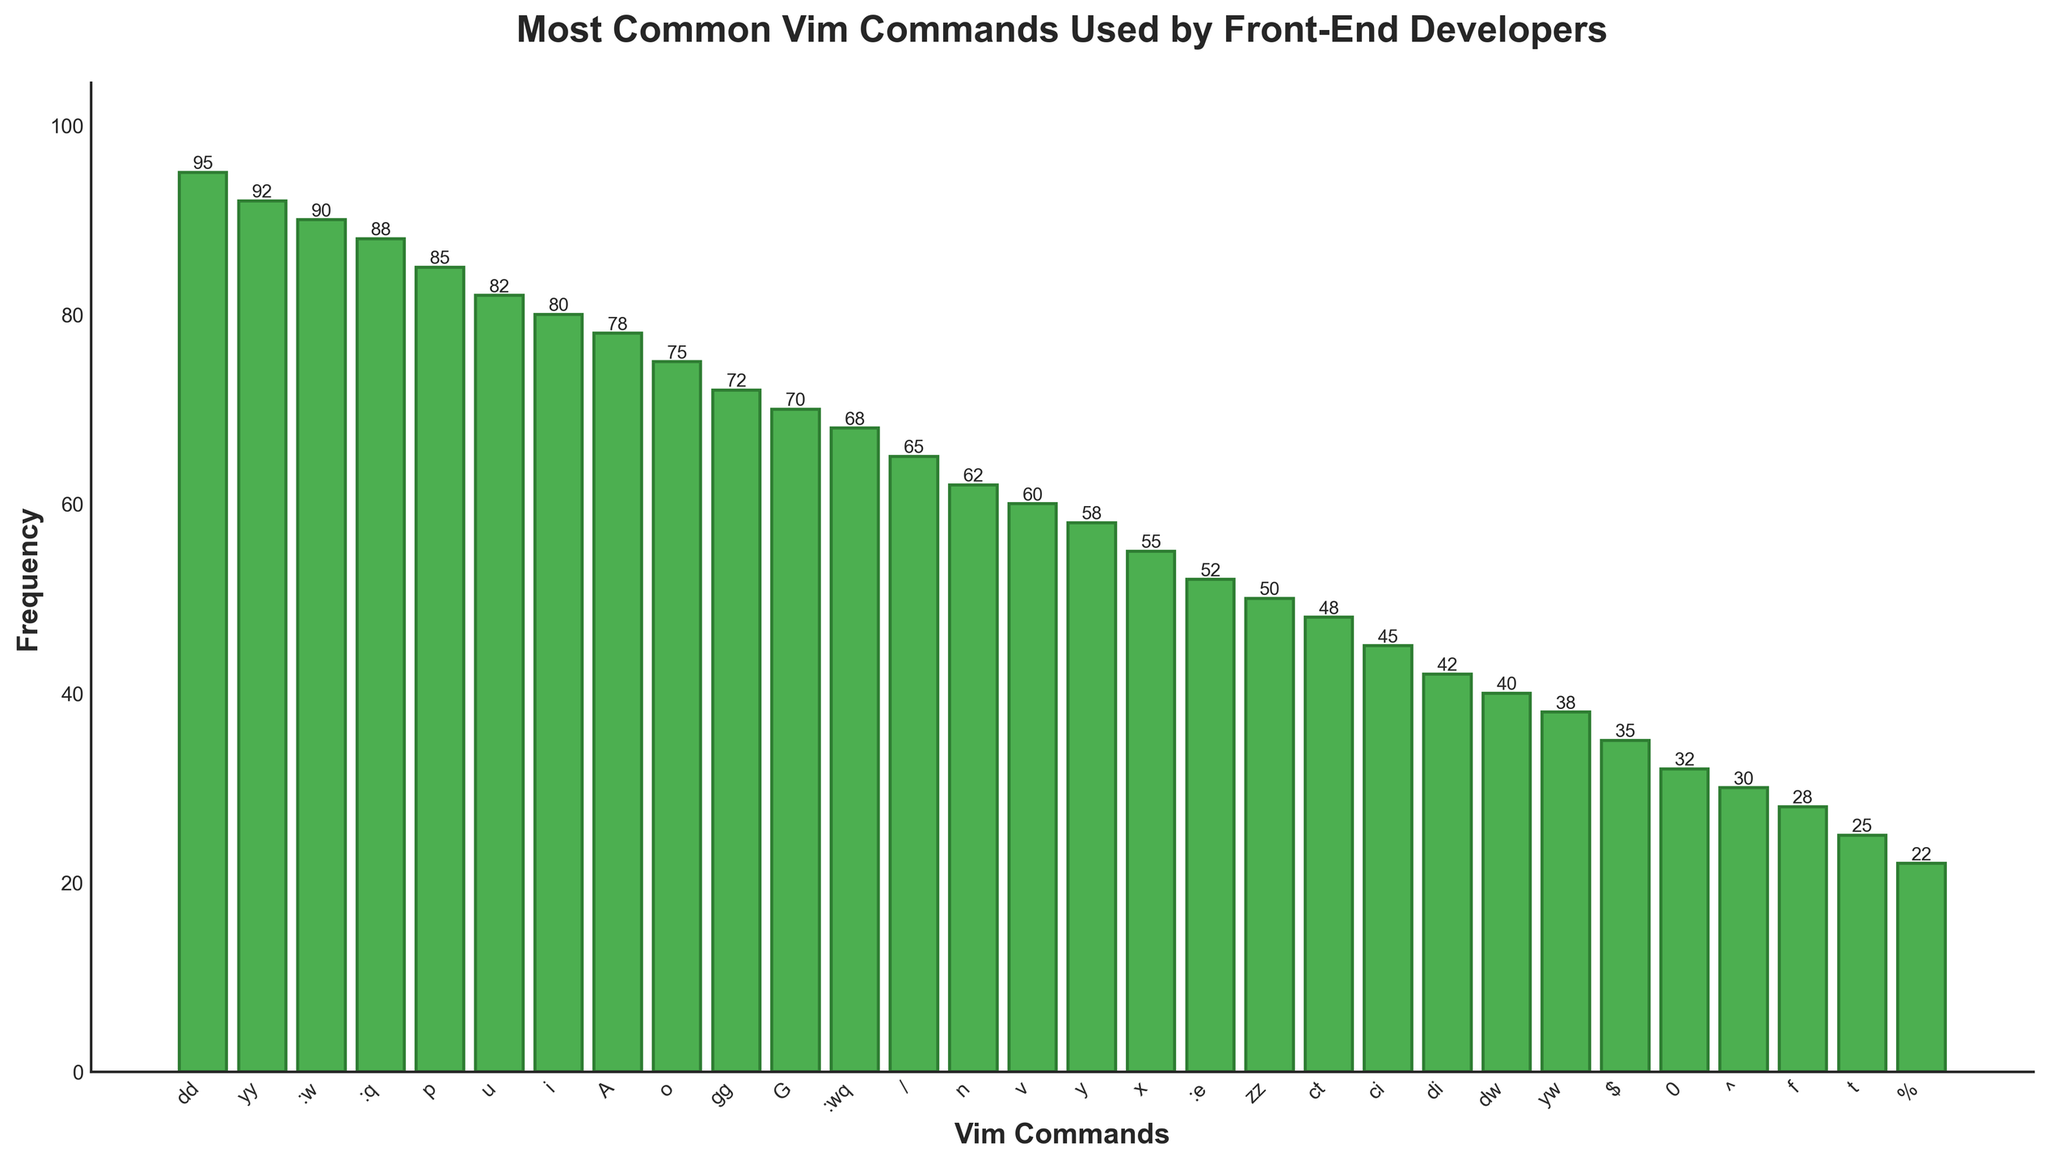Which Vim command has the highest frequency? The bar with the highest frequency is the tallest one. From the figure, "dd" has the highest frequency of 95.
Answer: dd What is the combined frequency of the commands "yy" and ":w"? Add the frequencies of "yy" and ":w". From the figure, "yy" has 92 and ":w" has 90. The combined frequency is 92 + 90 = 182.
Answer: 182 Which command is less frequent, "p" or "u"? Compare the heights of the bars for "p" and "u". The bar for "p" is slightly taller (85) than the bar for "u" (82).
Answer: u How many more times is the "dd" command used compared to the "ci" command? Subtract the frequency of "ci" from the frequency of "dd". "dd" has 95 and "ci" has 45, so 95 - 45 = 50.
Answer: 50 Which commands have a frequency between 70 and 80? Look for bars with heights between 70 and 80. The commands "A" (78) and "o" (75), and "gg" (72) are within this range.
Answer: A, o, gg What is the average frequency of the three most common commands? Determine the frequencies of the three tallest bars ("dd" 95, "yy" 92, ":w" 90), then calculate the average: (95 + 92 + 90) / 3 = 92.33.
Answer: 92.33 Is the frequency of ":wq" greater or less than the frequency of the "n" command? Compare the heights of the bars for ":wq" and "n". ":wq" has a frequency of 68, while "n" has a frequency of 62.
Answer: Greater How many commands have a frequency of at least 50? Count the bars with heights of 50 or more. There are 14 commands with frequencies of 50 or higher.
Answer: 14 What is the median frequency of the commands shown? Determine the middle value in the ordered list of frequencies. With 30 data points, the median is the average of the 15th and 16th values. Values from lowest to highest: 22, 25, 28, 30, 32, 35, 38, 40, 42, 45, 48, 50, 52, 55, 58, 60, 62, 65, 68, 70, 72, 75, 78, 80, 82, 85, 88, 90, 92, 95. Median is (58+60)/2 = 59.
Answer: 59 